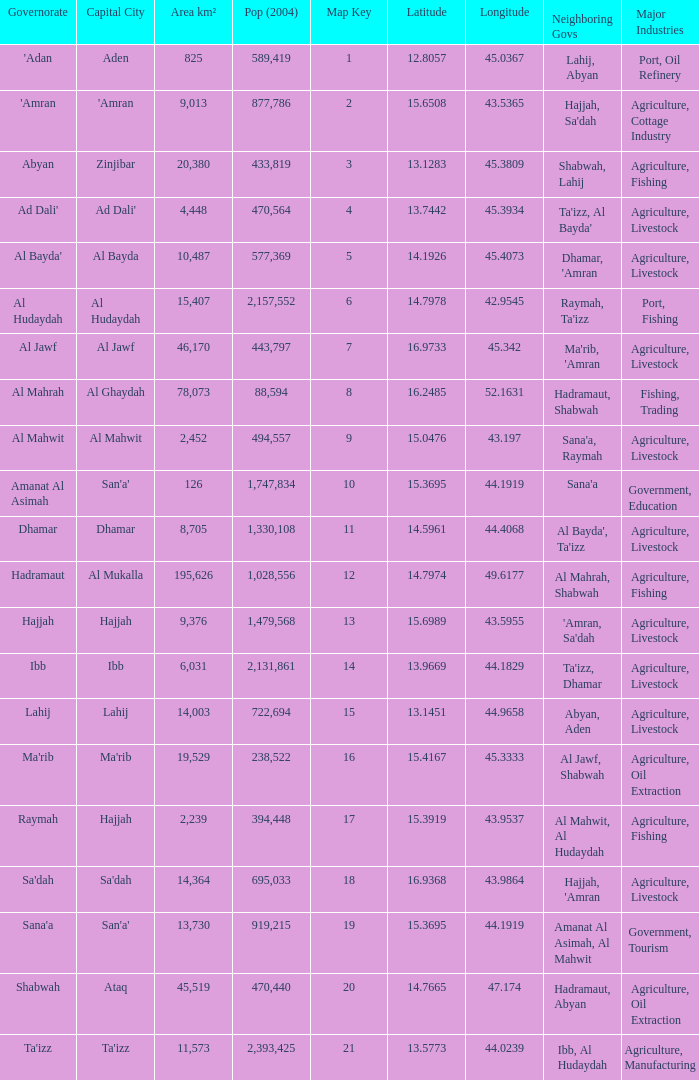Count the sum of Pop (2004) which has a Governorate of al mahrah with an Area km² smaller than 78,073? None. 